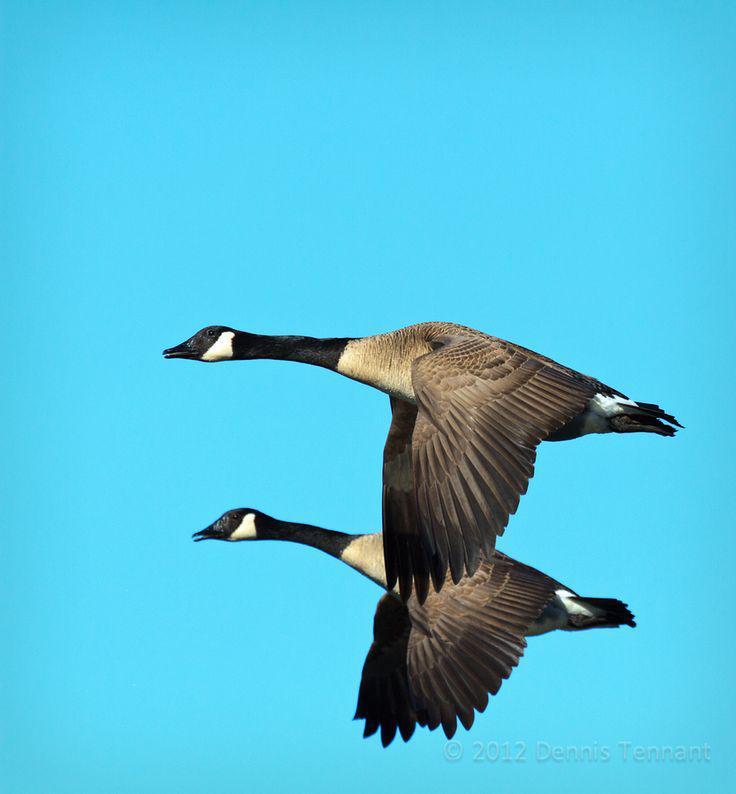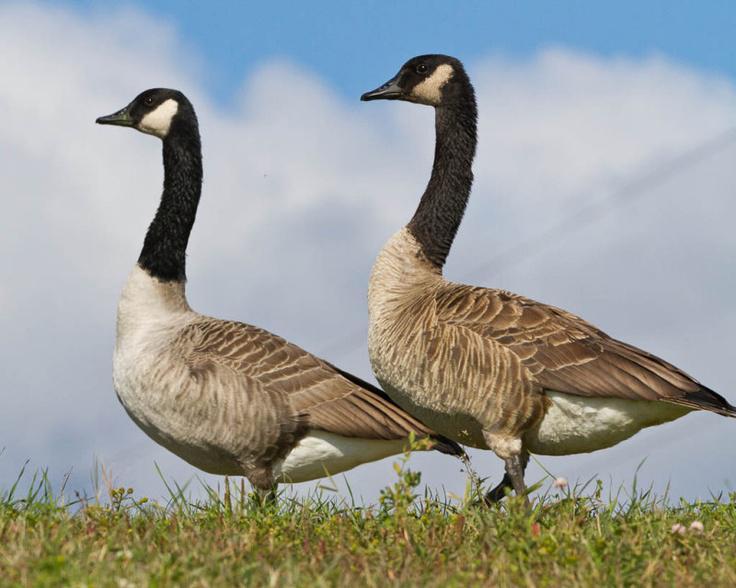The first image is the image on the left, the second image is the image on the right. Examine the images to the left and right. Is the description "There are two birds in the right image both facing towards the left." accurate? Answer yes or no. Yes. The first image is the image on the left, the second image is the image on the right. Given the left and right images, does the statement "Two black-necked geese with backs to the camera are standing in water." hold true? Answer yes or no. No. 